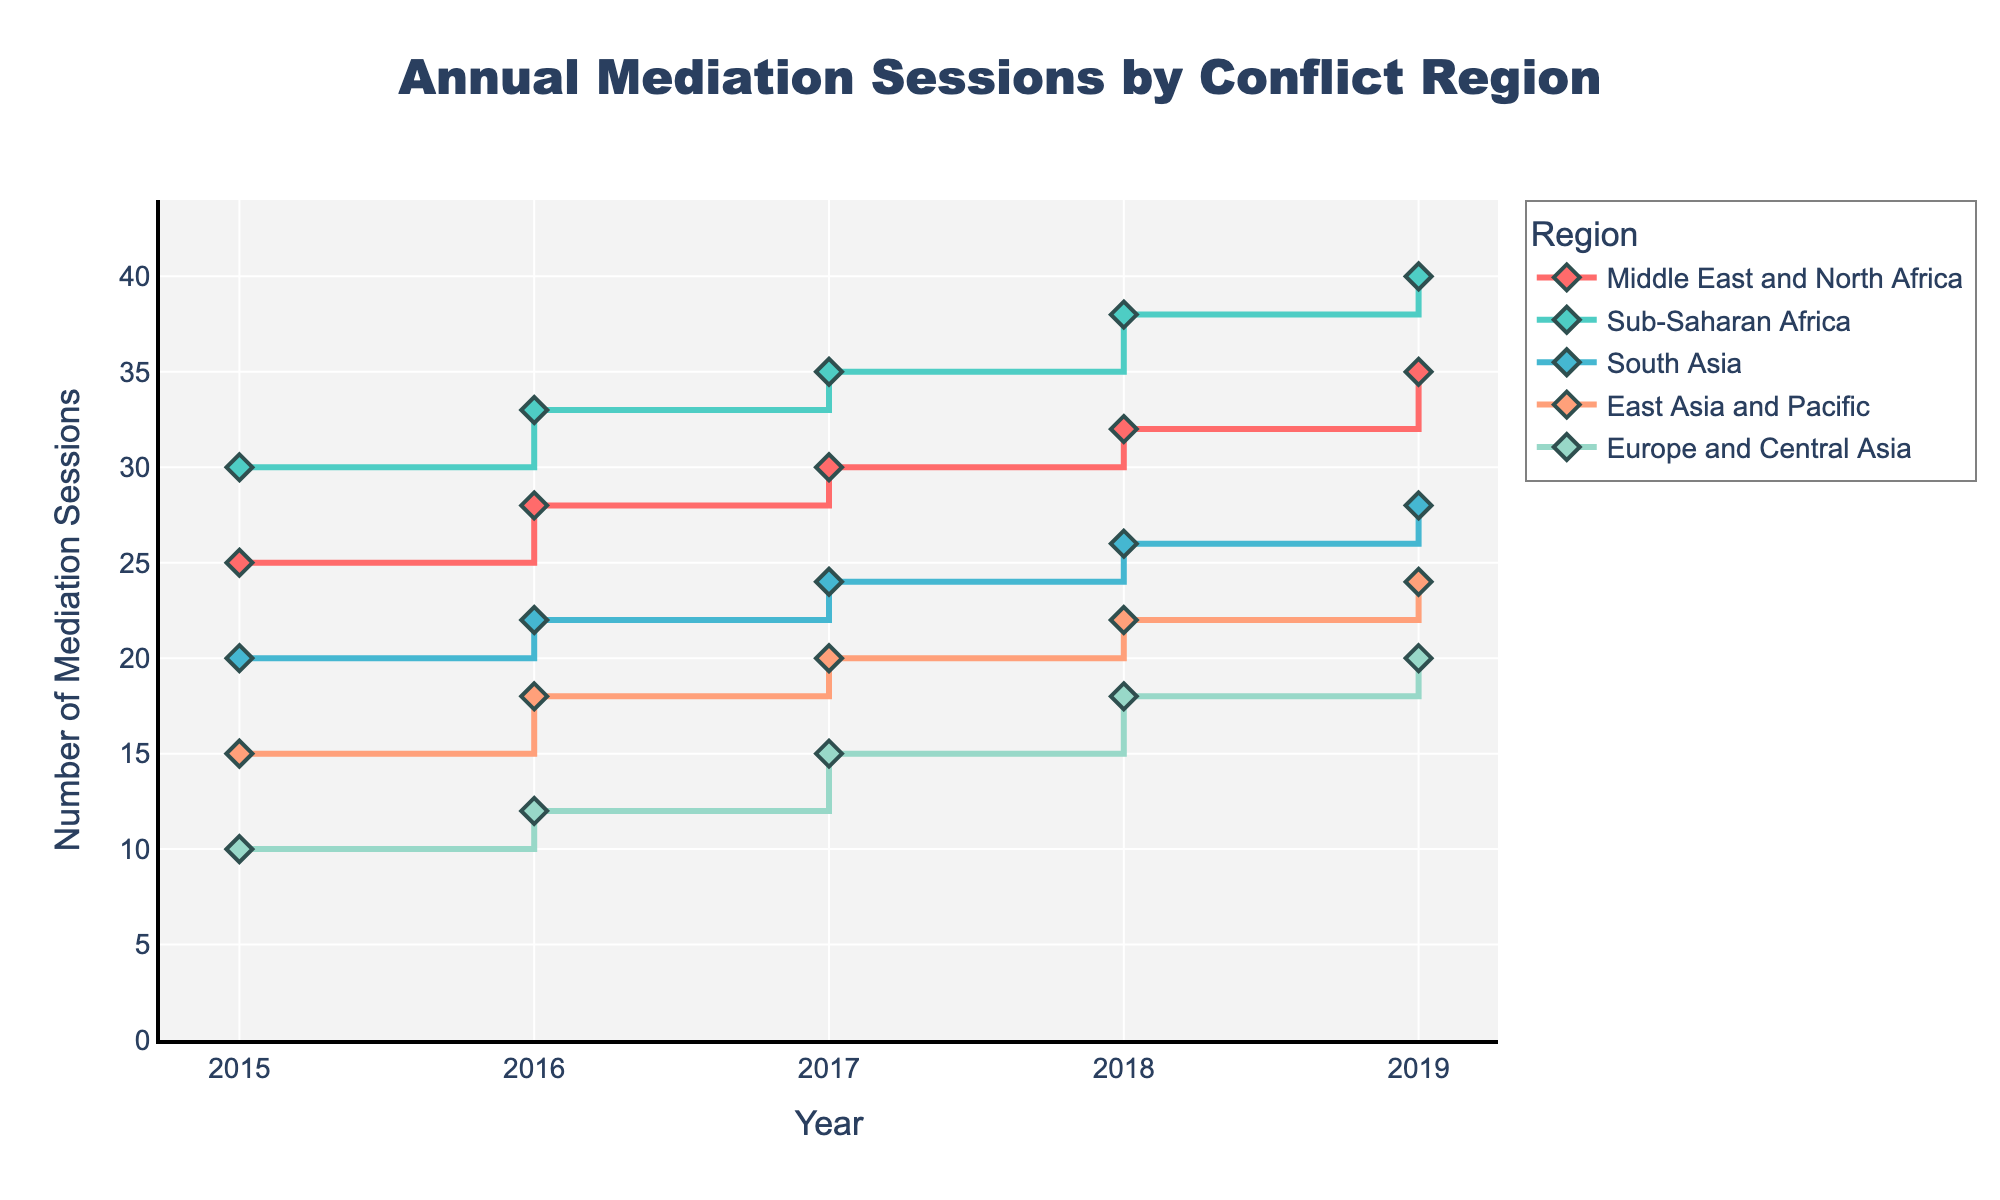How many mediation sessions were held in the Middle East and North Africa in 2017? According to the plot, locate the point for the year 2017 along the x-axis. On this same vertical, find the value of the point associated with 'Middle East and North Africa' which is 30 mediation sessions.
Answer: 30 Which region had the highest number of mediation sessions in 2019? Observe the points for the year 2019 for each region and identify the highest value. The region with the highest point for 2019 is 'Sub-Saharan Africa' with 40 mediation sessions.
Answer: Sub-Saharan Africa What is the overall trend in the number of mediation sessions in East Asia and Pacific from 2015 to 2019? Track the points for 'East Asia and Pacific' from 2015 to 2019. Notice the values rise from 15 in 2015 to 24 in 2019, indicating an increasing trend.
Answer: Increasing How does the number of mediation sessions in South Asia in 2016 compare to the number in 2018? Find the number of sessions for 'South Asia' in 2016 which is 22, and in 2018 which is 26. Compare these values to see that 2018 had 4 more sessions than 2016.
Answer: 4 more in 2018 What is the difference in the number of mediation sessions between Europe and Central Asia in 2015 and 2019? Identify the number of sessions for 'Europe and Central Asia' in 2015 which is 10, and in 2019 which is 20. The difference is 20 - 10 = 10 sessions.
Answer: 10 How many regions experienced an increase in the number of mediation sessions every year from 2015 to 2019? Look at the plot points year by year for each region and check whether the number increases every year. 'Sub-Saharan Africa' is the only region where the number of mediation sessions increased every single year.
Answer: 1 What was the total number of mediation sessions across all regions in 2018? Add the values for all regions in 2018: 32 (Middle East and North Africa) + 38 (Sub-Saharan Africa) + 26 (South Asia) + 22 (East Asia and Pacific) + 18 (Europe and Central Asia) = 136
Answer: 136 Which region showed the smallest change in the number of mediation sessions from 2015 to 2019? Measure the difference in the number of sessions between 2015 and 2019 for each region. 'Europe and Central Asia' has the smallest change, increasing from 10 in 2015 to 20 in 2019, showing a change of 10 sessions.
Answer: Europe and Central Asia 